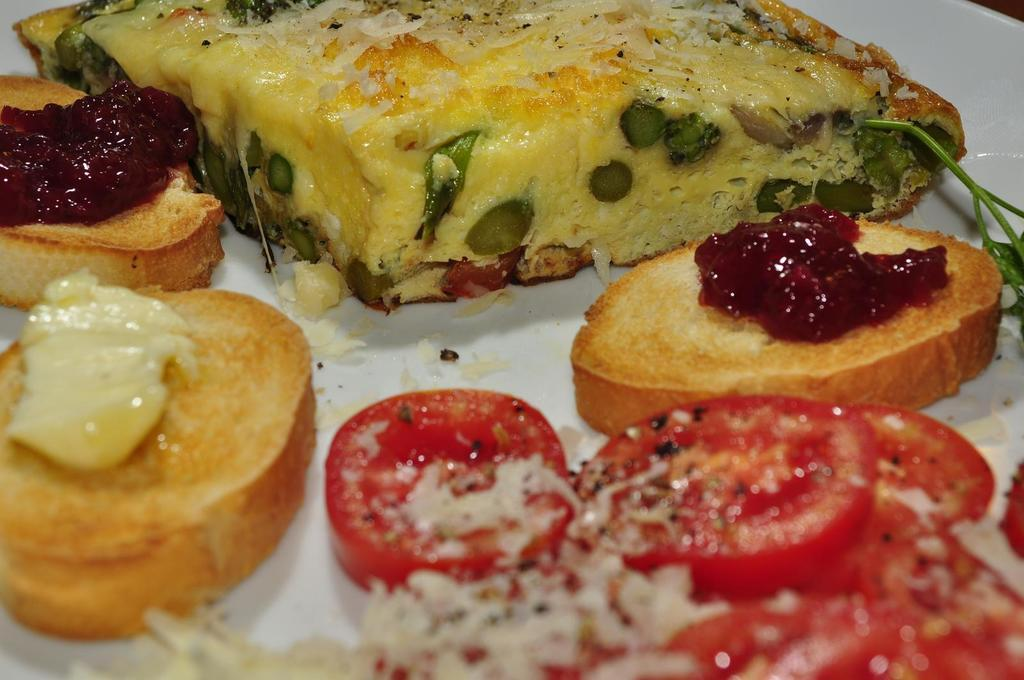What type of objects can be seen in the image? There are food items in the image. How are the food items arranged or contained? The food items are kept in a white color bowl. Where is the bowl located in the image? The bowl is located in the middle of the image. What type of game is being played by the person in the image? There is no person or game present in the image; it only features food items in a white color bowl. 